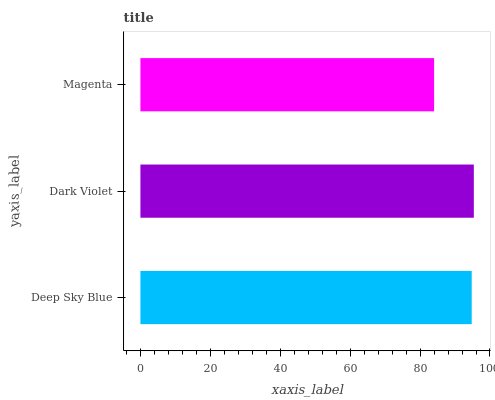Is Magenta the minimum?
Answer yes or no. Yes. Is Dark Violet the maximum?
Answer yes or no. Yes. Is Dark Violet the minimum?
Answer yes or no. No. Is Magenta the maximum?
Answer yes or no. No. Is Dark Violet greater than Magenta?
Answer yes or no. Yes. Is Magenta less than Dark Violet?
Answer yes or no. Yes. Is Magenta greater than Dark Violet?
Answer yes or no. No. Is Dark Violet less than Magenta?
Answer yes or no. No. Is Deep Sky Blue the high median?
Answer yes or no. Yes. Is Deep Sky Blue the low median?
Answer yes or no. Yes. Is Dark Violet the high median?
Answer yes or no. No. Is Magenta the low median?
Answer yes or no. No. 